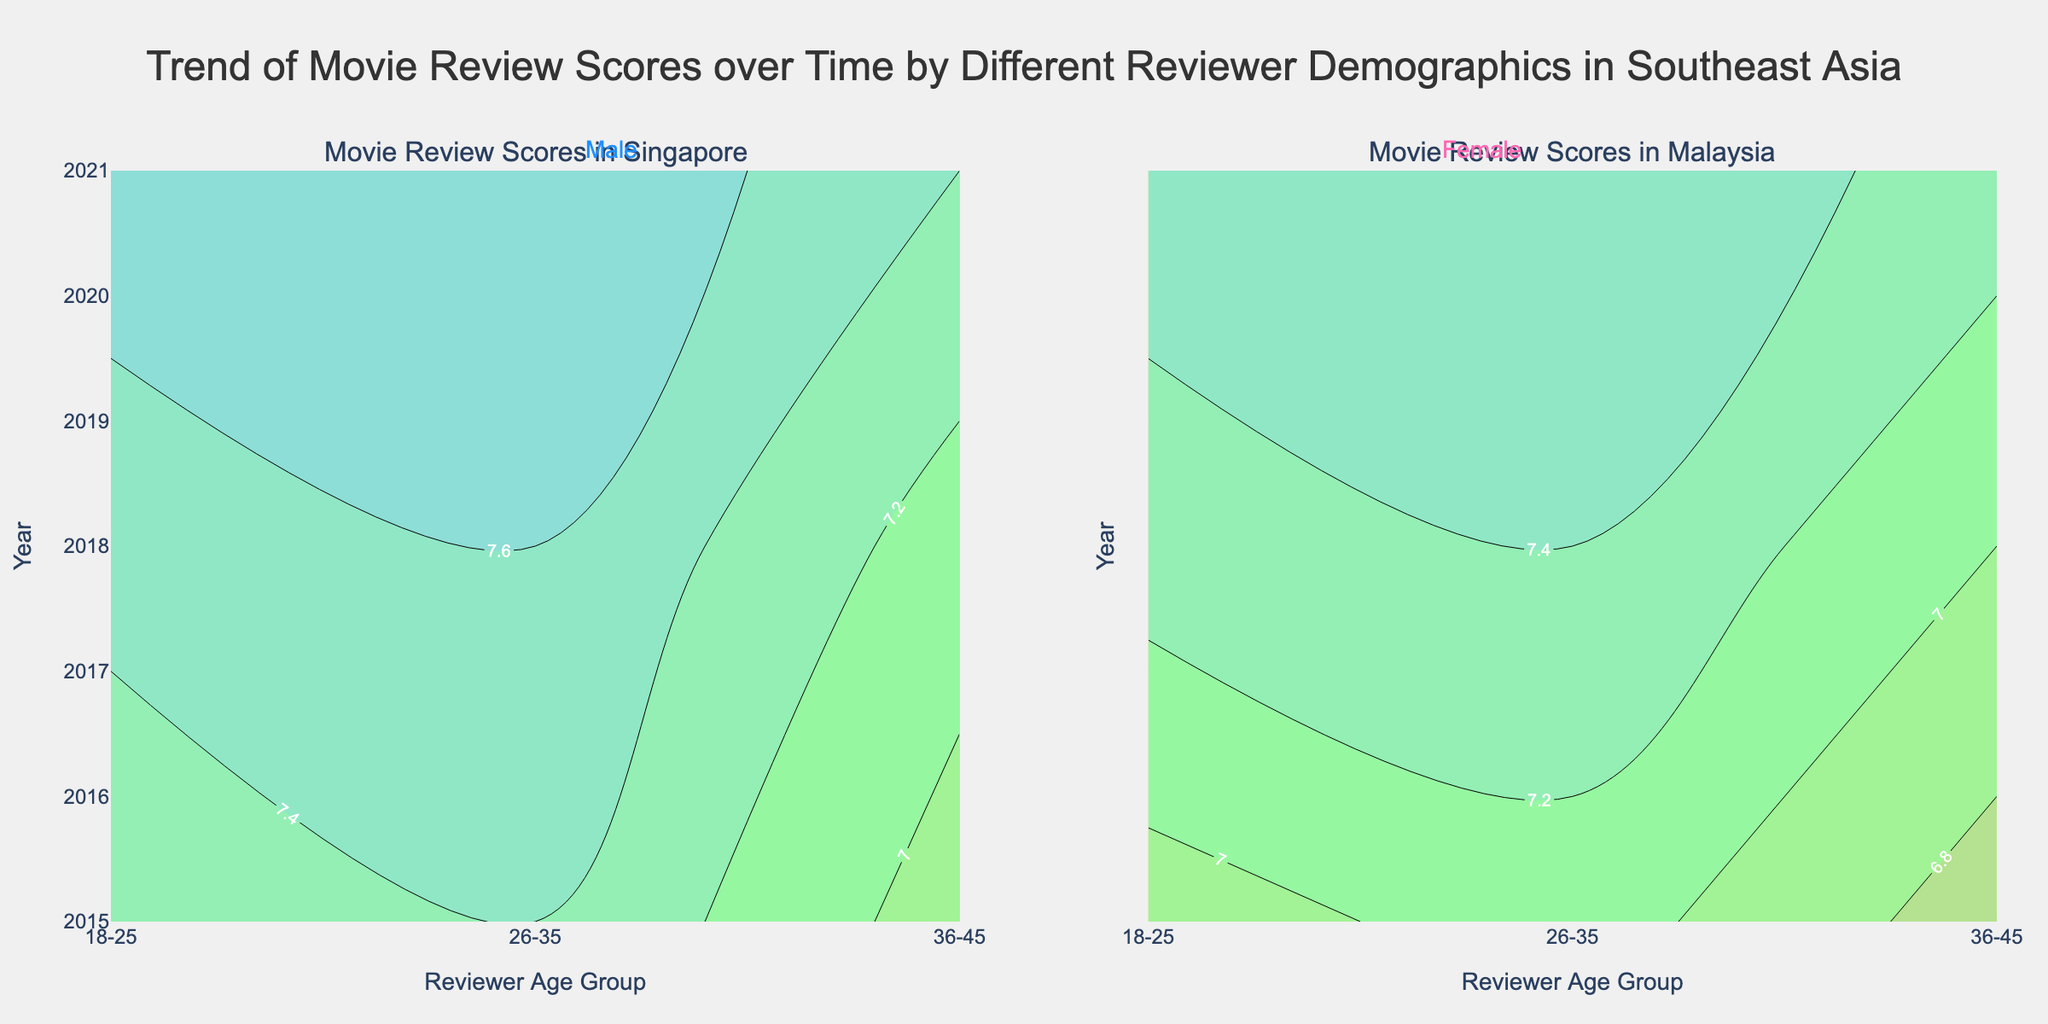What is the title of the plot? The title is prominently displayed at the top of the figure and reads "Trend of Movie Review Scores over Time by Different Reviewer Demographics in Southeast Asia."
Answer: Trend of Movie Review Scores over Time by Different Reviewer Demographics in Southeast Asia Which countries are depicted in the subplot titles? The subplot titles in the figure indicate the two different countries, namely "Singapore" and "Malaysia."
Answer: Singapore and Malaysia What are the y-axis labels used in the contour plots? The y-axis is labeled "Year," which can be seen on both subplots and shows the progression from 2015 through 2021.
Answer: Year What is the range of average scores used in the contour plots? The contours in both subplots are colored and labeled, indicating that the range of average scores starts at 6 and ends at 8.
Answer: 6 to 8 How do the review scores for the age group 18-25 change in Singapore between 2015 and 2021? The review scores for both male and female reviewers aged 18-25 in Singapore show an increasing trend from around 6.8-7.2 in 2015 to around 7.2-7.7 in 2021.
Answer: Increasing trend How does the review score trend for Malaysian females aged 26-35 compare to that of Singaporean males of the same age group? In Malaysia, female reviewers aged 26-35 showed an increase in review scores from around 7.1 in 2015 to approximately 7.6 in 2021. In Singapore, male reviewers of the same age group showed a similar increasing trend from around 7.0 in 2015 to about 7.5 in 2021.
Answer: Both increasing trend Between male and female reviewers in Singapore, which gender had higher review scores for the 26-35 age group in 2018? From the contour plot, female reviewers in the 26-35 age group had higher review scores (around 7.6) compared to male reviewers (around 7.3) in Singapore in 2018.
Answer: Female Which age group in Malaysia had the lowest average review score in 2021, and what was the score? The 36-45 age group, particularly male reviewers, had the lowest average review score in Malaysia in 2021, with a score of approximately 6.8.
Answer: 36-45 (male) How did female reviewers aged 18-25 in Singapore rate movies on average compared to males of the same age group in 2021? Female reviewers aged 18-25 in Singapore rated movies higher (7.7) compared to their male counterparts (7.2) in 2021.
Answer: Females rated higher What is the general trend for movie review scores over time for both genders in both countries? In both Singapore and Malaysia, the general trend shows that movie review scores have increased over time from 2015 to 2021 for both male and female reviewers.
Answer: Increasing trend 